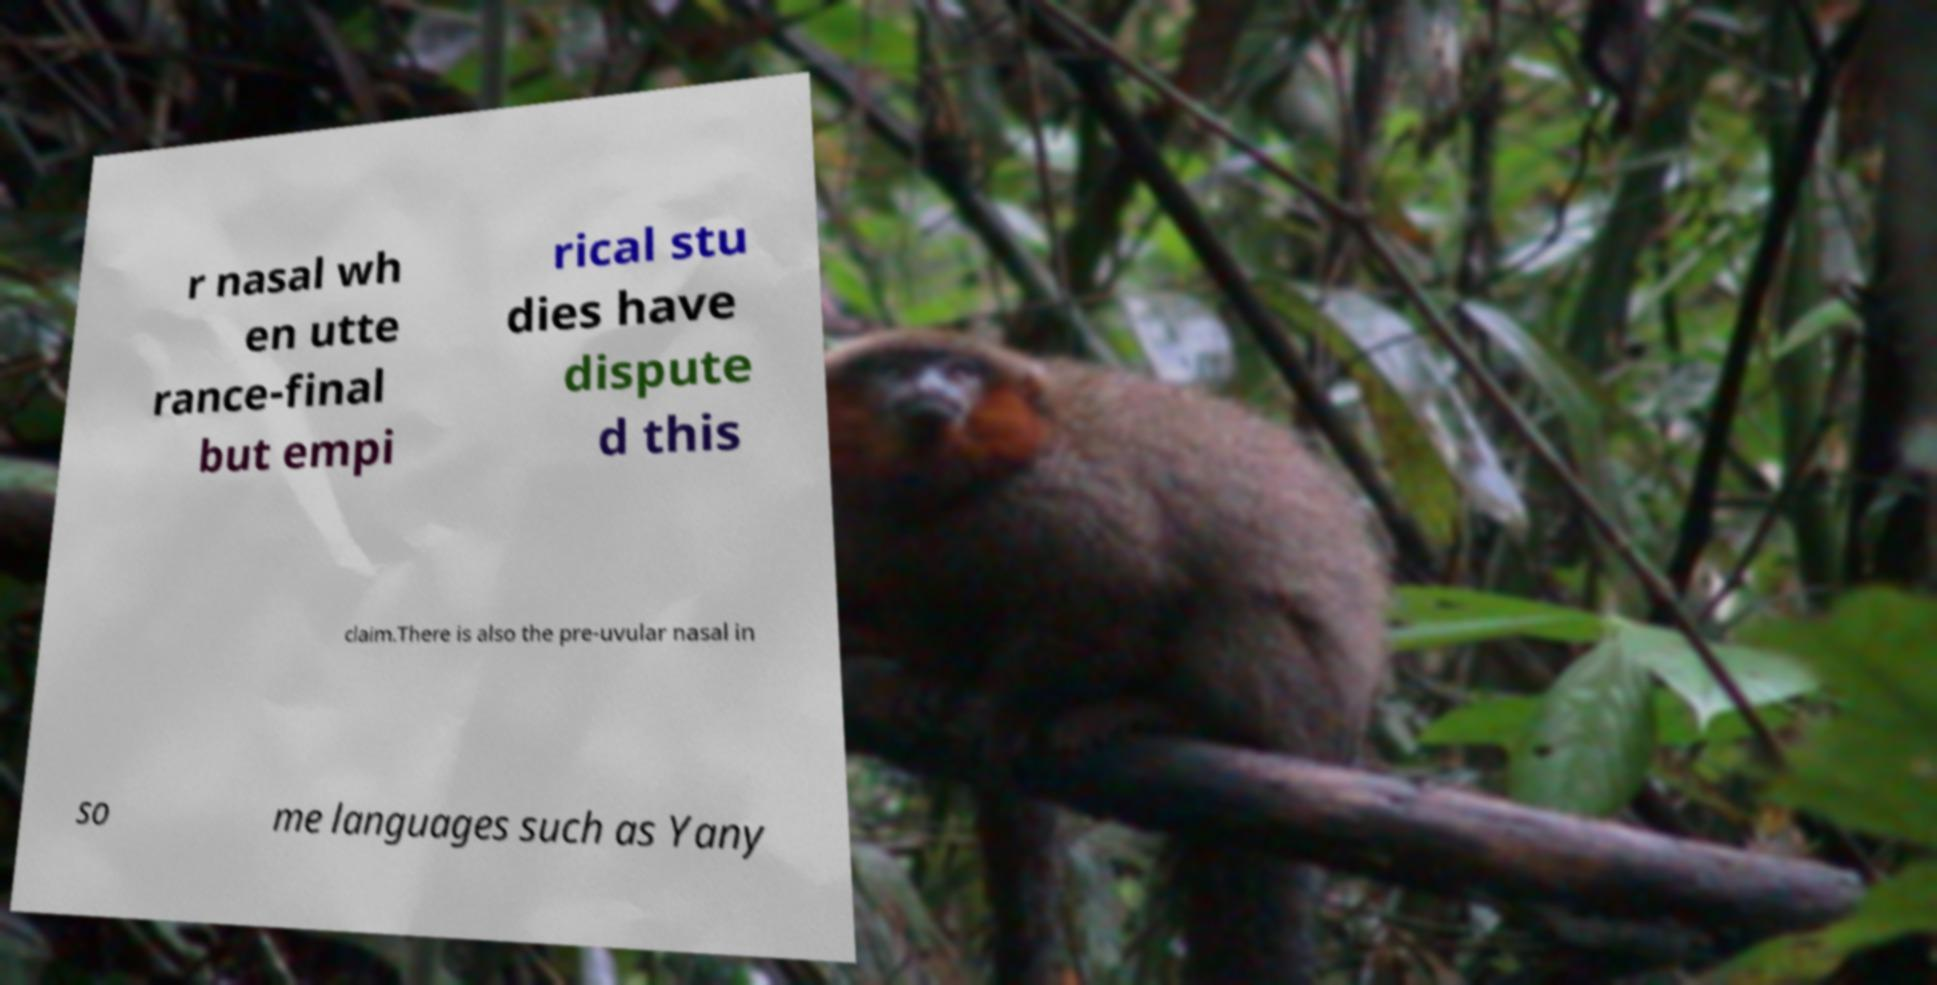Can you accurately transcribe the text from the provided image for me? r nasal wh en utte rance-final but empi rical stu dies have dispute d this claim.There is also the pre-uvular nasal in so me languages such as Yany 